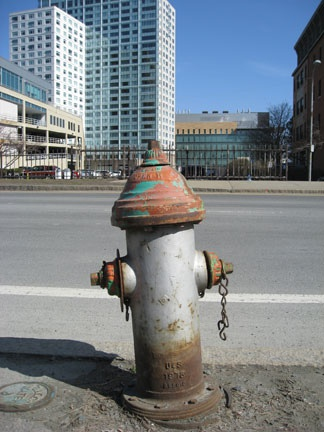Describe the objects in this image and their specific colors. I can see fire hydrant in gray, black, darkgray, and lightgray tones, car in gray, black, and maroon tones, car in gray, darkgray, black, and lightgray tones, car in gray, darkgray, lightgray, and black tones, and car in gray and black tones in this image. 